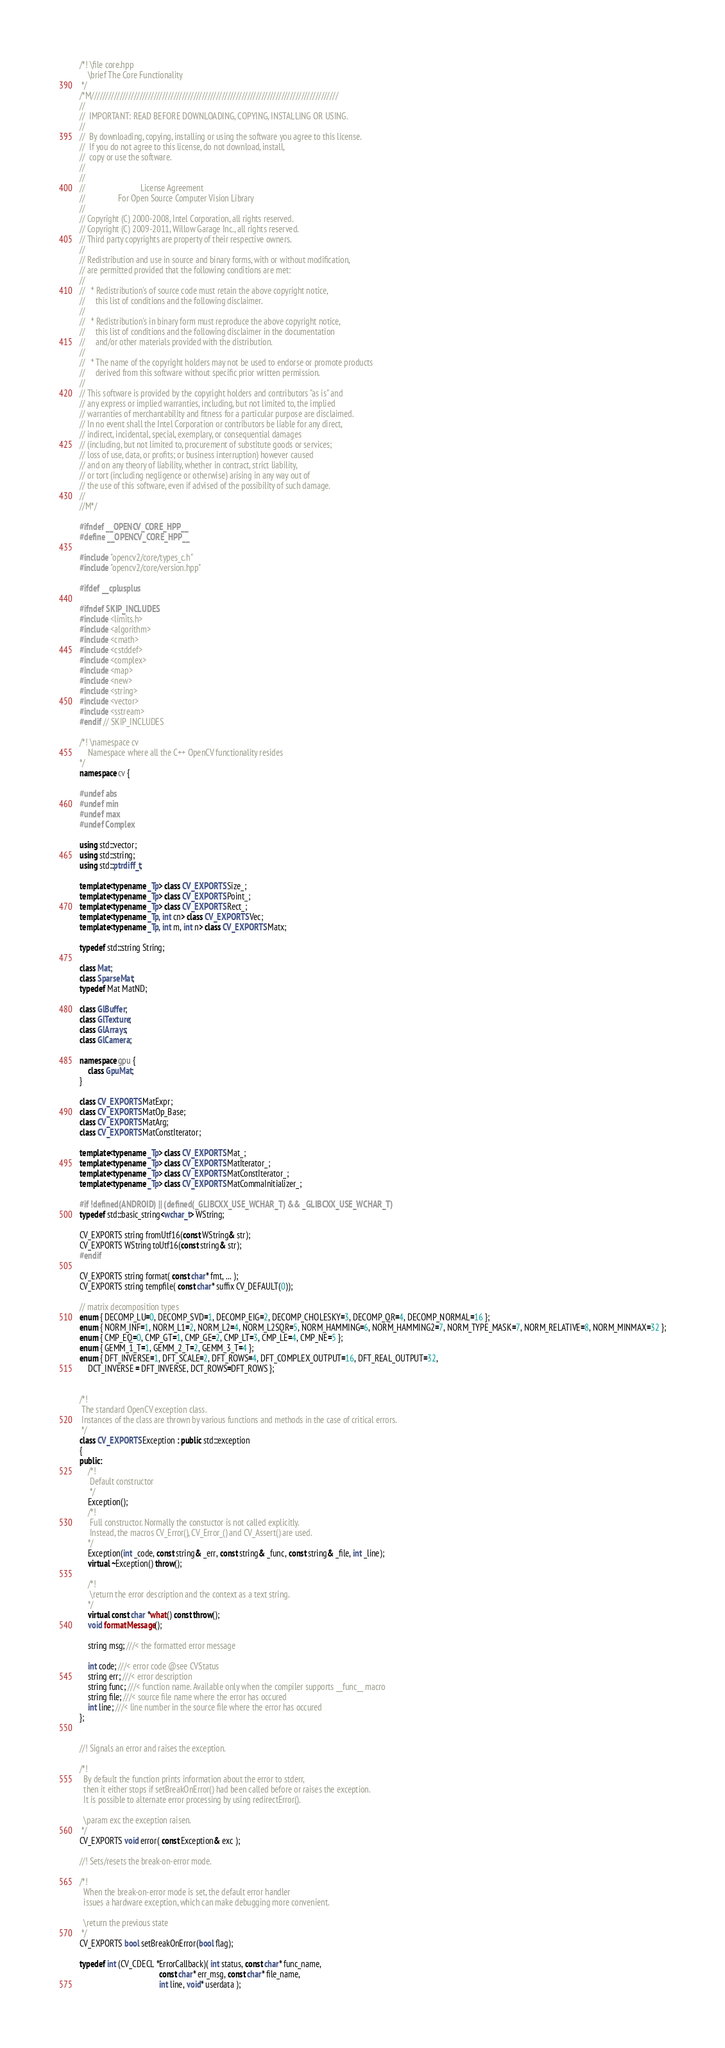<code> <loc_0><loc_0><loc_500><loc_500><_C++_>/*! \file core.hpp
    \brief The Core Functionality
 */
/*M///////////////////////////////////////////////////////////////////////////////////////
//
//  IMPORTANT: READ BEFORE DOWNLOADING, COPYING, INSTALLING OR USING.
//
//  By downloading, copying, installing or using the software you agree to this license.
//  If you do not agree to this license, do not download, install,
//  copy or use the software.
//
//
//                           License Agreement
//                For Open Source Computer Vision Library
//
// Copyright (C) 2000-2008, Intel Corporation, all rights reserved.
// Copyright (C) 2009-2011, Willow Garage Inc., all rights reserved.
// Third party copyrights are property of their respective owners.
//
// Redistribution and use in source and binary forms, with or without modification,
// are permitted provided that the following conditions are met:
//
//   * Redistribution's of source code must retain the above copyright notice,
//     this list of conditions and the following disclaimer.
//
//   * Redistribution's in binary form must reproduce the above copyright notice,
//     this list of conditions and the following disclaimer in the documentation
//     and/or other materials provided with the distribution.
//
//   * The name of the copyright holders may not be used to endorse or promote products
//     derived from this software without specific prior written permission.
//
// This software is provided by the copyright holders and contributors "as is" and
// any express or implied warranties, including, but not limited to, the implied
// warranties of merchantability and fitness for a particular purpose are disclaimed.
// In no event shall the Intel Corporation or contributors be liable for any direct,
// indirect, incidental, special, exemplary, or consequential damages
// (including, but not limited to, procurement of substitute goods or services;
// loss of use, data, or profits; or business interruption) however caused
// and on any theory of liability, whether in contract, strict liability,
// or tort (including negligence or otherwise) arising in any way out of
// the use of this software, even if advised of the possibility of such damage.
//
//M*/

#ifndef __OPENCV_CORE_HPP__
#define __OPENCV_CORE_HPP__

#include "opencv2/core/types_c.h"
#include "opencv2/core/version.hpp"

#ifdef __cplusplus

#ifndef SKIP_INCLUDES
#include <limits.h>
#include <algorithm>
#include <cmath>
#include <cstddef>
#include <complex>
#include <map>
#include <new>
#include <string>
#include <vector>
#include <sstream>
#endif // SKIP_INCLUDES

/*! \namespace cv
    Namespace where all the C++ OpenCV functionality resides
*/
namespace cv {

#undef abs
#undef min
#undef max
#undef Complex

using std::vector;
using std::string;
using std::ptrdiff_t;

template<typename _Tp> class CV_EXPORTS Size_;
template<typename _Tp> class CV_EXPORTS Point_;
template<typename _Tp> class CV_EXPORTS Rect_;
template<typename _Tp, int cn> class CV_EXPORTS Vec;
template<typename _Tp, int m, int n> class CV_EXPORTS Matx;

typedef std::string String;

class Mat;
class SparseMat;
typedef Mat MatND;

class GlBuffer;
class GlTexture;
class GlArrays;
class GlCamera;

namespace gpu {
    class GpuMat;
}

class CV_EXPORTS MatExpr;
class CV_EXPORTS MatOp_Base;
class CV_EXPORTS MatArg;
class CV_EXPORTS MatConstIterator;

template<typename _Tp> class CV_EXPORTS Mat_;
template<typename _Tp> class CV_EXPORTS MatIterator_;
template<typename _Tp> class CV_EXPORTS MatConstIterator_;
template<typename _Tp> class CV_EXPORTS MatCommaInitializer_;

#if !defined(ANDROID) || (defined(_GLIBCXX_USE_WCHAR_T) && _GLIBCXX_USE_WCHAR_T)
typedef std::basic_string<wchar_t> WString;

CV_EXPORTS string fromUtf16(const WString& str);
CV_EXPORTS WString toUtf16(const string& str);
#endif

CV_EXPORTS string format( const char* fmt, ... );
CV_EXPORTS string tempfile( const char* suffix CV_DEFAULT(0));

// matrix decomposition types
enum { DECOMP_LU=0, DECOMP_SVD=1, DECOMP_EIG=2, DECOMP_CHOLESKY=3, DECOMP_QR=4, DECOMP_NORMAL=16 };
enum { NORM_INF=1, NORM_L1=2, NORM_L2=4, NORM_L2SQR=5, NORM_HAMMING=6, NORM_HAMMING2=7, NORM_TYPE_MASK=7, NORM_RELATIVE=8, NORM_MINMAX=32 };
enum { CMP_EQ=0, CMP_GT=1, CMP_GE=2, CMP_LT=3, CMP_LE=4, CMP_NE=5 };
enum { GEMM_1_T=1, GEMM_2_T=2, GEMM_3_T=4 };
enum { DFT_INVERSE=1, DFT_SCALE=2, DFT_ROWS=4, DFT_COMPLEX_OUTPUT=16, DFT_REAL_OUTPUT=32,
    DCT_INVERSE = DFT_INVERSE, DCT_ROWS=DFT_ROWS };


/*!
 The standard OpenCV exception class.
 Instances of the class are thrown by various functions and methods in the case of critical errors.
 */
class CV_EXPORTS Exception : public std::exception
{
public:
    /*!
     Default constructor
     */
    Exception();
    /*!
     Full constructor. Normally the constuctor is not called explicitly.
     Instead, the macros CV_Error(), CV_Error_() and CV_Assert() are used.
    */
    Exception(int _code, const string& _err, const string& _func, const string& _file, int _line);
    virtual ~Exception() throw();

    /*!
     \return the error description and the context as a text string.
    */
    virtual const char *what() const throw();
    void formatMessage();

    string msg; ///< the formatted error message

    int code; ///< error code @see CVStatus
    string err; ///< error description
    string func; ///< function name. Available only when the compiler supports __func__ macro
    string file; ///< source file name where the error has occured
    int line; ///< line number in the source file where the error has occured
};


//! Signals an error and raises the exception.

/*!
  By default the function prints information about the error to stderr,
  then it either stops if setBreakOnError() had been called before or raises the exception.
  It is possible to alternate error processing by using redirectError().

  \param exc the exception raisen.
 */
CV_EXPORTS void error( const Exception& exc );

//! Sets/resets the break-on-error mode.

/*!
  When the break-on-error mode is set, the default error handler
  issues a hardware exception, which can make debugging more convenient.

  \return the previous state
 */
CV_EXPORTS bool setBreakOnError(bool flag);

typedef int (CV_CDECL *ErrorCallback)( int status, const char* func_name,
                                       const char* err_msg, const char* file_name,
                                       int line, void* userdata );
</code> 